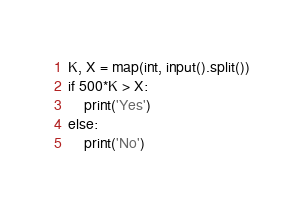Convert code to text. <code><loc_0><loc_0><loc_500><loc_500><_Python_>K, X = map(int, input().split())
if 500*K > X:
    print('Yes')
else:
    print('No')</code> 